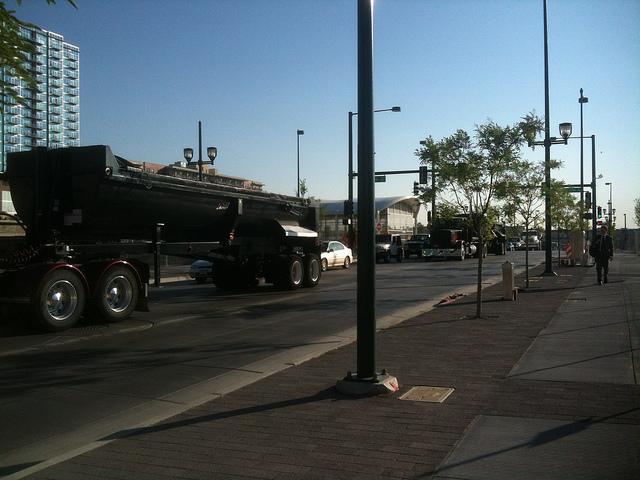How many trees are there?
Keep it brief. 4. Is the day cloudy?
Give a very brief answer. No. What kind of trees?
Give a very brief answer. Oak. Is this a transportation station?
Concise answer only. No. What color is the truck on the middle left?
Keep it brief. Black. Are there many cars on the street?
Be succinct. Yes. What is pictured moving in the photo?
Give a very brief answer. Truck. Are clouds visible?
Concise answer only. No. Are the trees saying hello to the person on the sidewalk?
Quick response, please. No. What is approaching in the distance?
Be succinct. Truck. 